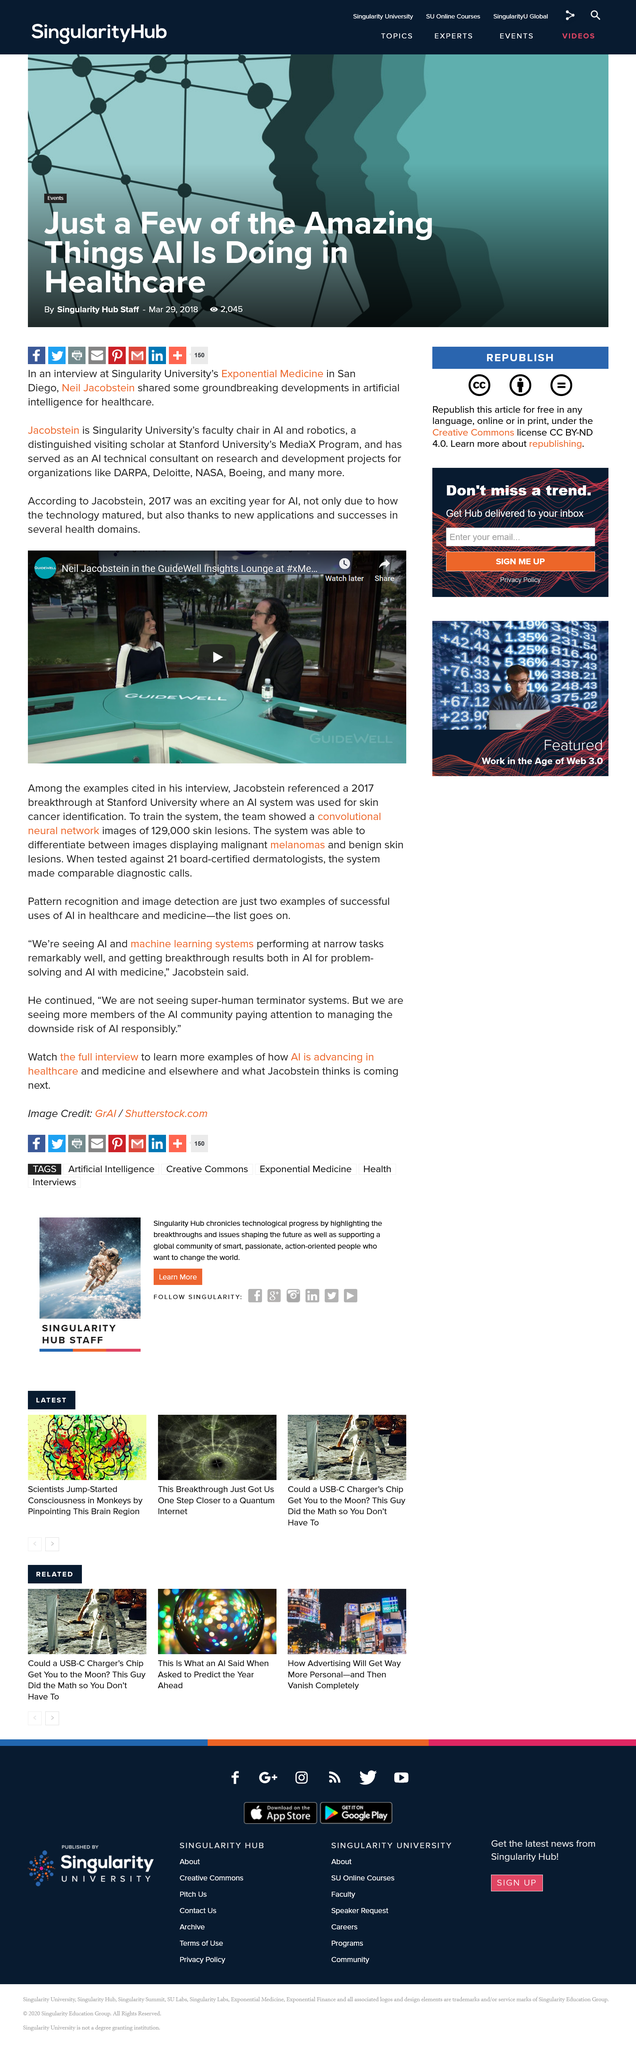List a handful of essential elements in this visual. The team presented the neural network with 129,000 images of skin lesions. Neil Jacobstein is being interviewed in the video. Pattern recognition is a successful use of AI in healthcare and medicine. Yes, it is. 